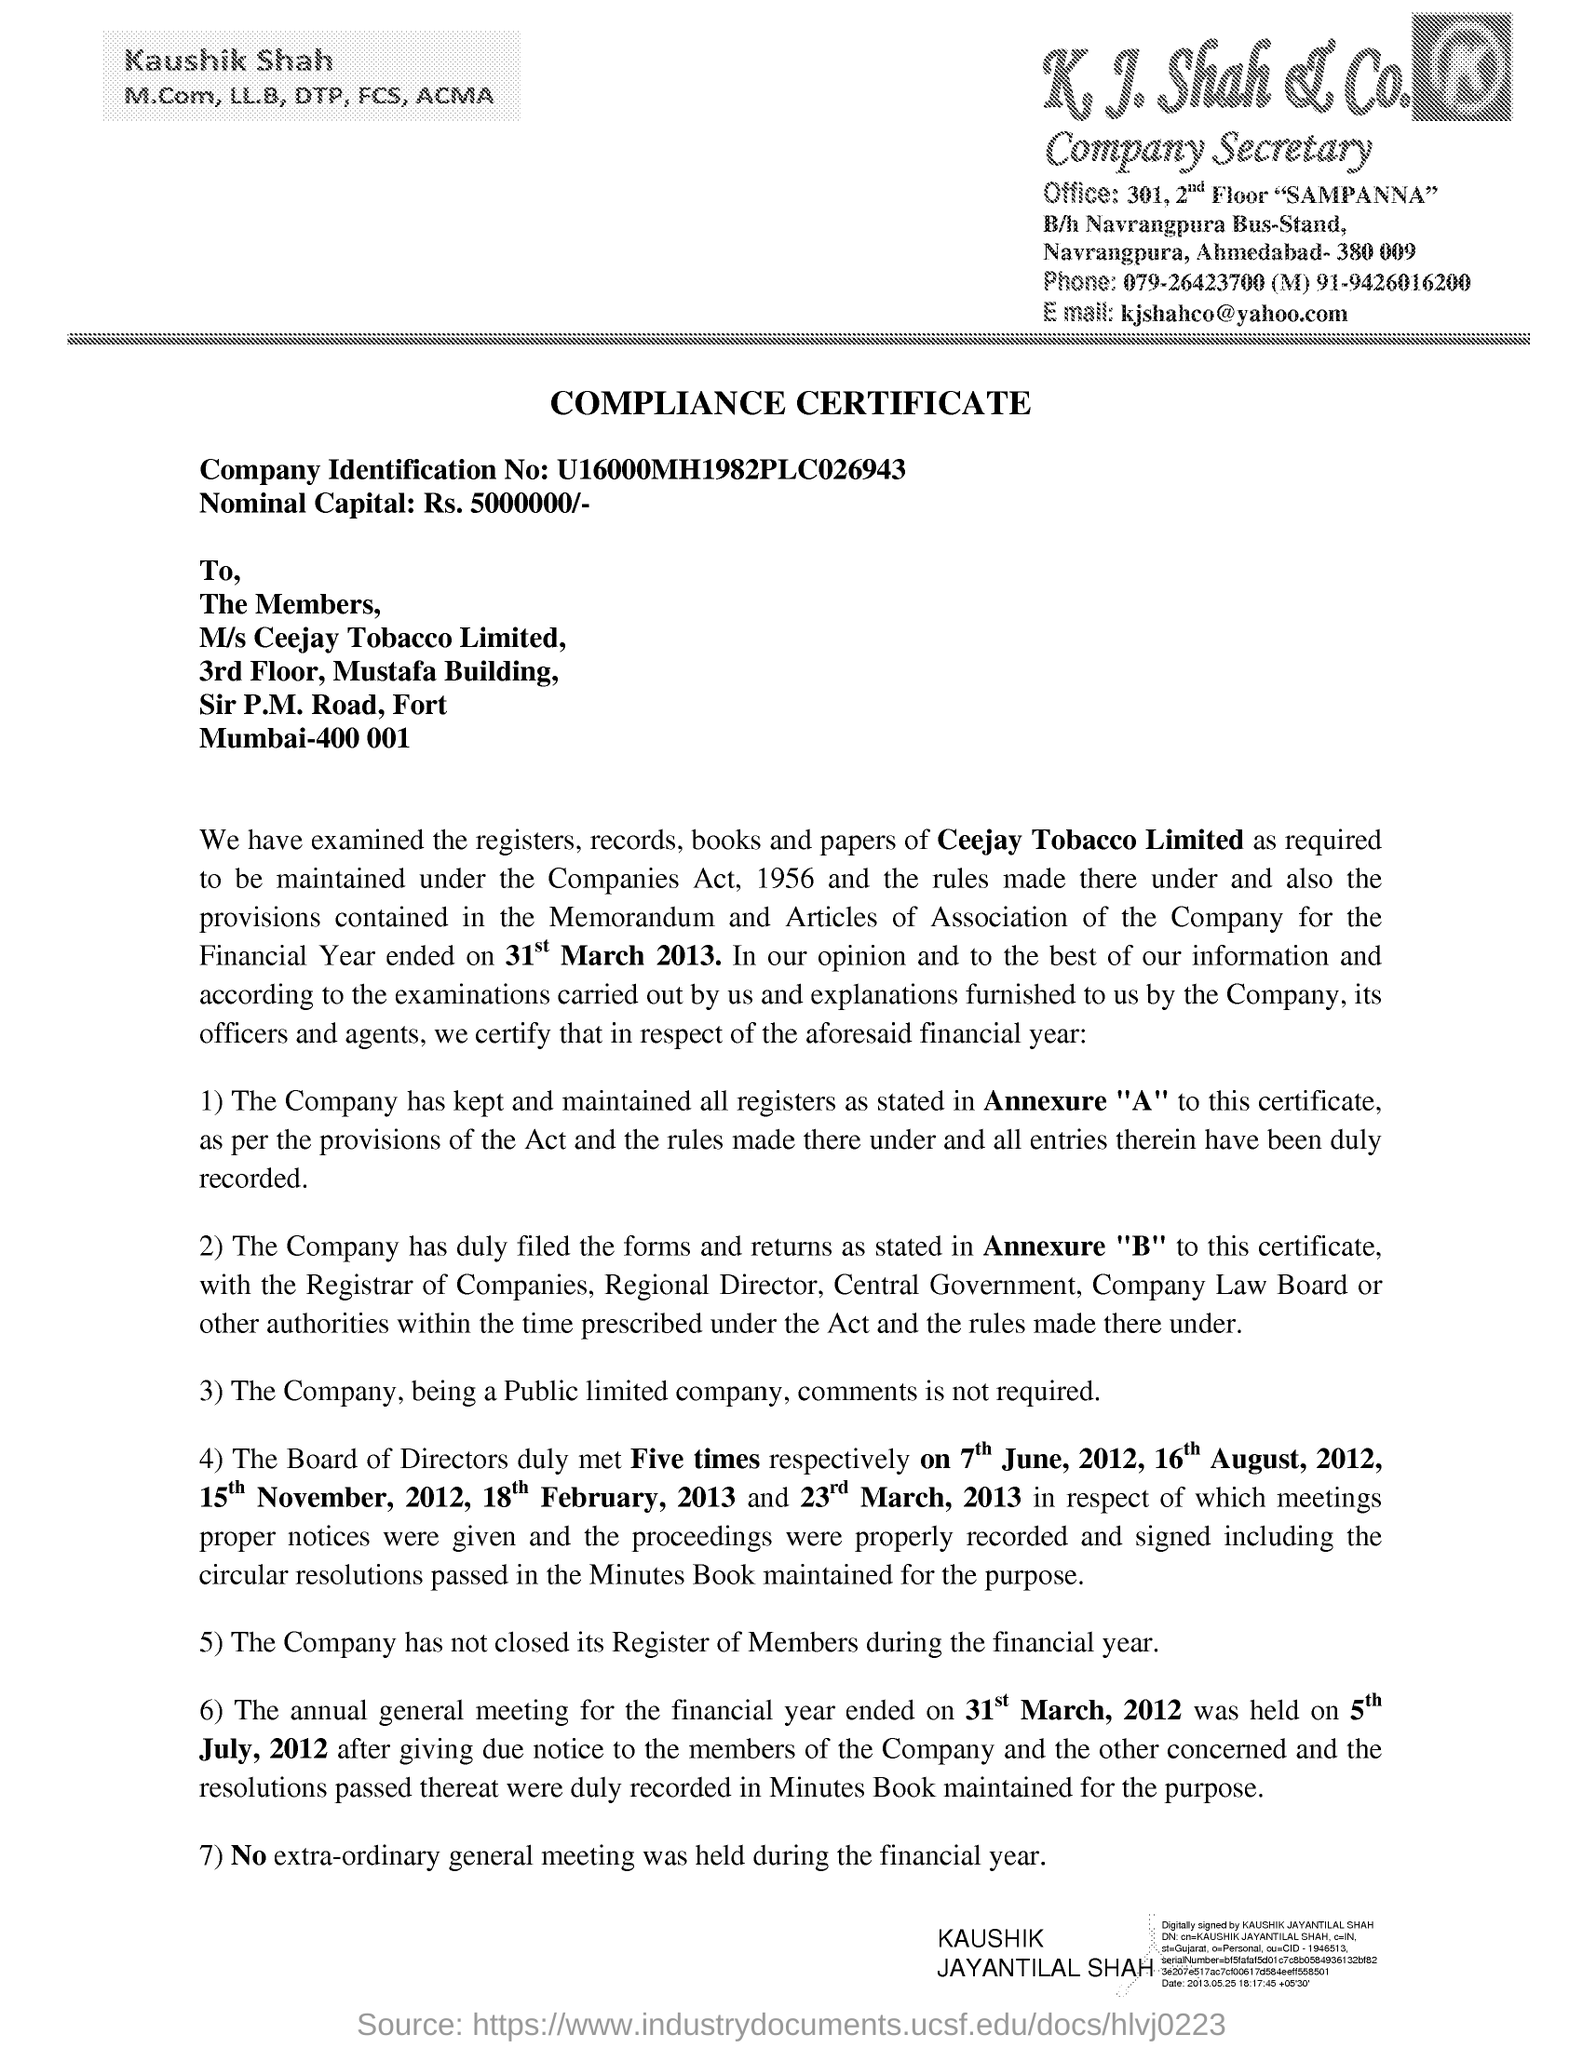What type of Certificate is given here?
Offer a terse response. COMPLIANCE CERTIFICATE. What is the Company Identification No given in the document?
Your answer should be very brief. U16000mh1982plc026943. What is the Nominal Capital mentioned in the document?
Your answer should be compact. Rs. 5000000/-. Which company is mentioned in the header of the document?
Your answer should be very brief. K. J. Shah & Co. 